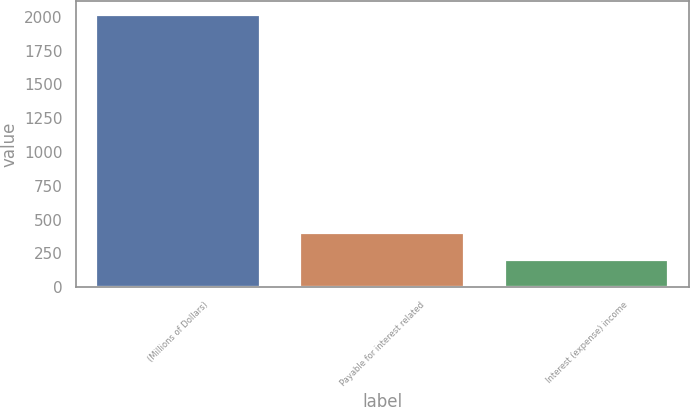Convert chart. <chart><loc_0><loc_0><loc_500><loc_500><bar_chart><fcel>(Millions of Dollars)<fcel>Payable for interest related<fcel>Interest (expense) income<nl><fcel>2016<fcel>403.28<fcel>201.69<nl></chart> 